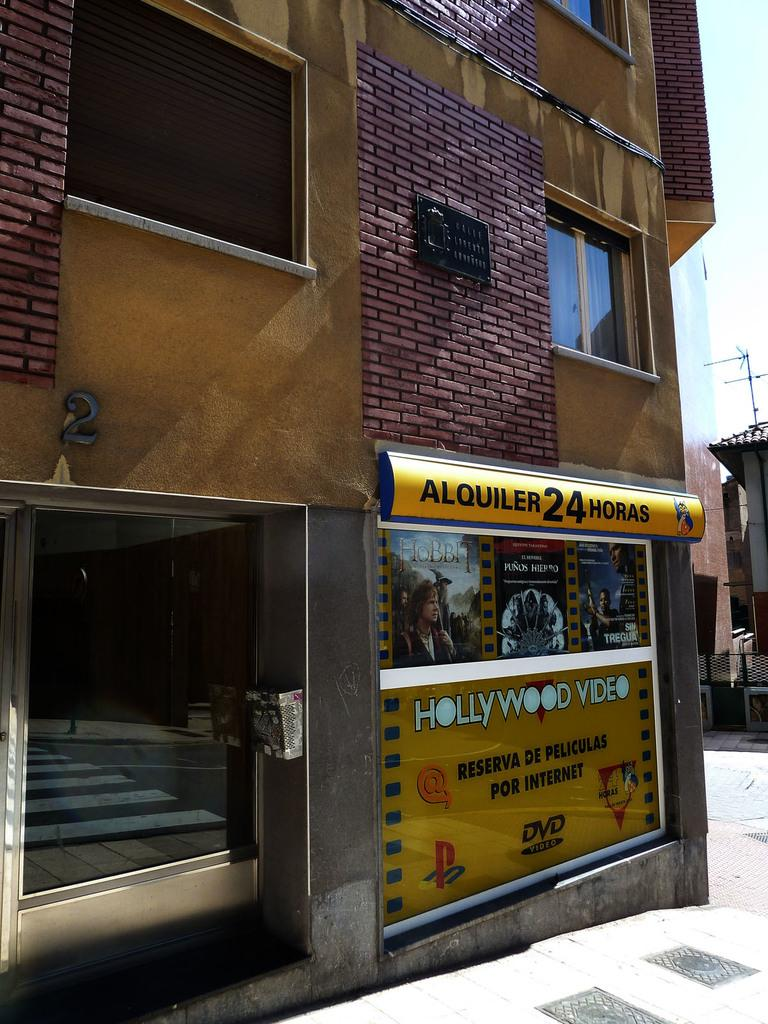<image>
Describe the image concisely. A Hollywood video that is located outside somewhere 